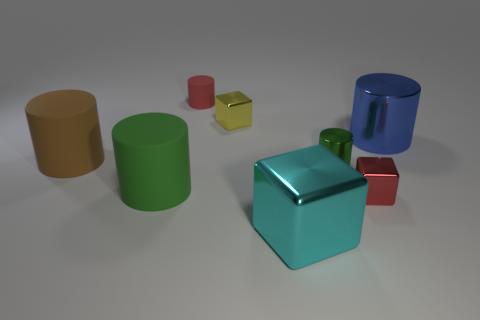Subtract 1 cylinders. How many cylinders are left? 4 Subtract all brown cylinders. How many cylinders are left? 4 Subtract all brown matte cylinders. How many cylinders are left? 4 Subtract all purple cylinders. Subtract all cyan spheres. How many cylinders are left? 5 Add 2 large blue metallic things. How many objects exist? 10 Subtract all blocks. How many objects are left? 5 Subtract 0 purple cubes. How many objects are left? 8 Subtract all big brown cylinders. Subtract all brown matte cylinders. How many objects are left? 6 Add 6 large cyan objects. How many large cyan objects are left? 7 Add 3 small yellow matte balls. How many small yellow matte balls exist? 3 